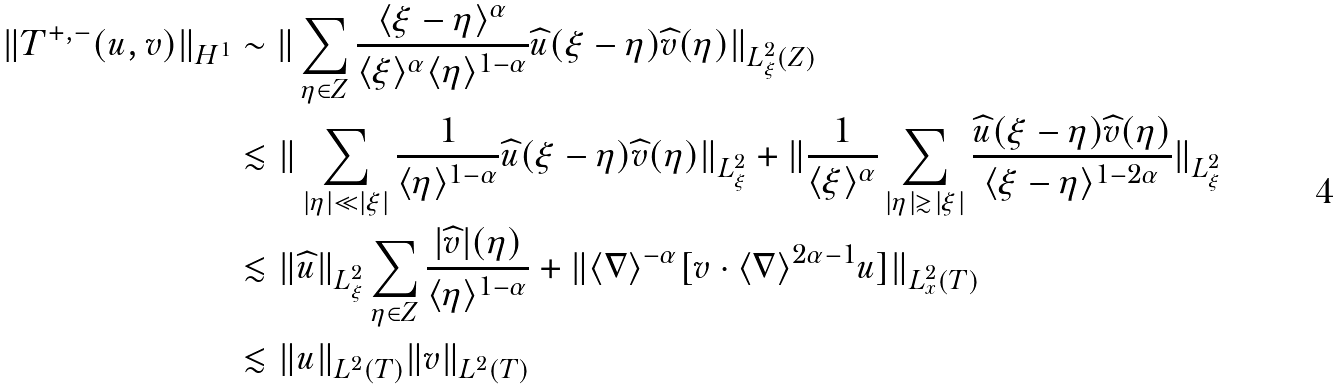<formula> <loc_0><loc_0><loc_500><loc_500>\| T ^ { + , - } ( u , v ) \| _ { H ^ { 1 } } & \sim \| \sum _ { \eta \in Z } \frac { \langle \xi - \eta \rangle ^ { \alpha } } { \langle \xi \rangle ^ { \alpha } \langle \eta \rangle ^ { 1 - \alpha } } \widehat { u } ( \xi - \eta ) \widehat { v } ( \eta ) \| _ { L ^ { 2 } _ { \xi } ( Z ) } \\ & \lesssim \| \sum _ { | \eta | \ll | \xi | } \frac { 1 } { \langle \eta \rangle ^ { 1 - \alpha } } \widehat { u } ( \xi - \eta ) \widehat { v } ( \eta ) \| _ { L ^ { 2 } _ { \xi } } + \| \frac { 1 } { \langle \xi \rangle ^ { \alpha } } \sum _ { | \eta | \gtrsim | \xi | } \frac { \widehat { u } ( \xi - \eta ) \widehat { v } ( \eta ) } { \langle \xi - \eta \rangle ^ { 1 - 2 \alpha } } \| _ { L ^ { 2 } _ { \xi } } \\ & \lesssim \| \widehat { u } \| _ { L ^ { 2 } _ { \xi } } \sum _ { \eta \in Z } \frac { | \widehat { v } | ( \eta ) } { \langle \eta \rangle ^ { 1 - \alpha } } + \| \langle \nabla \rangle ^ { - \alpha } [ v \cdot \langle \nabla \rangle ^ { 2 \alpha - 1 } u ] \| _ { L ^ { 2 } _ { x } ( T ) } \\ & \lesssim \| u \| _ { L ^ { 2 } ( T ) } \| v \| _ { L ^ { 2 } ( T ) }</formula> 